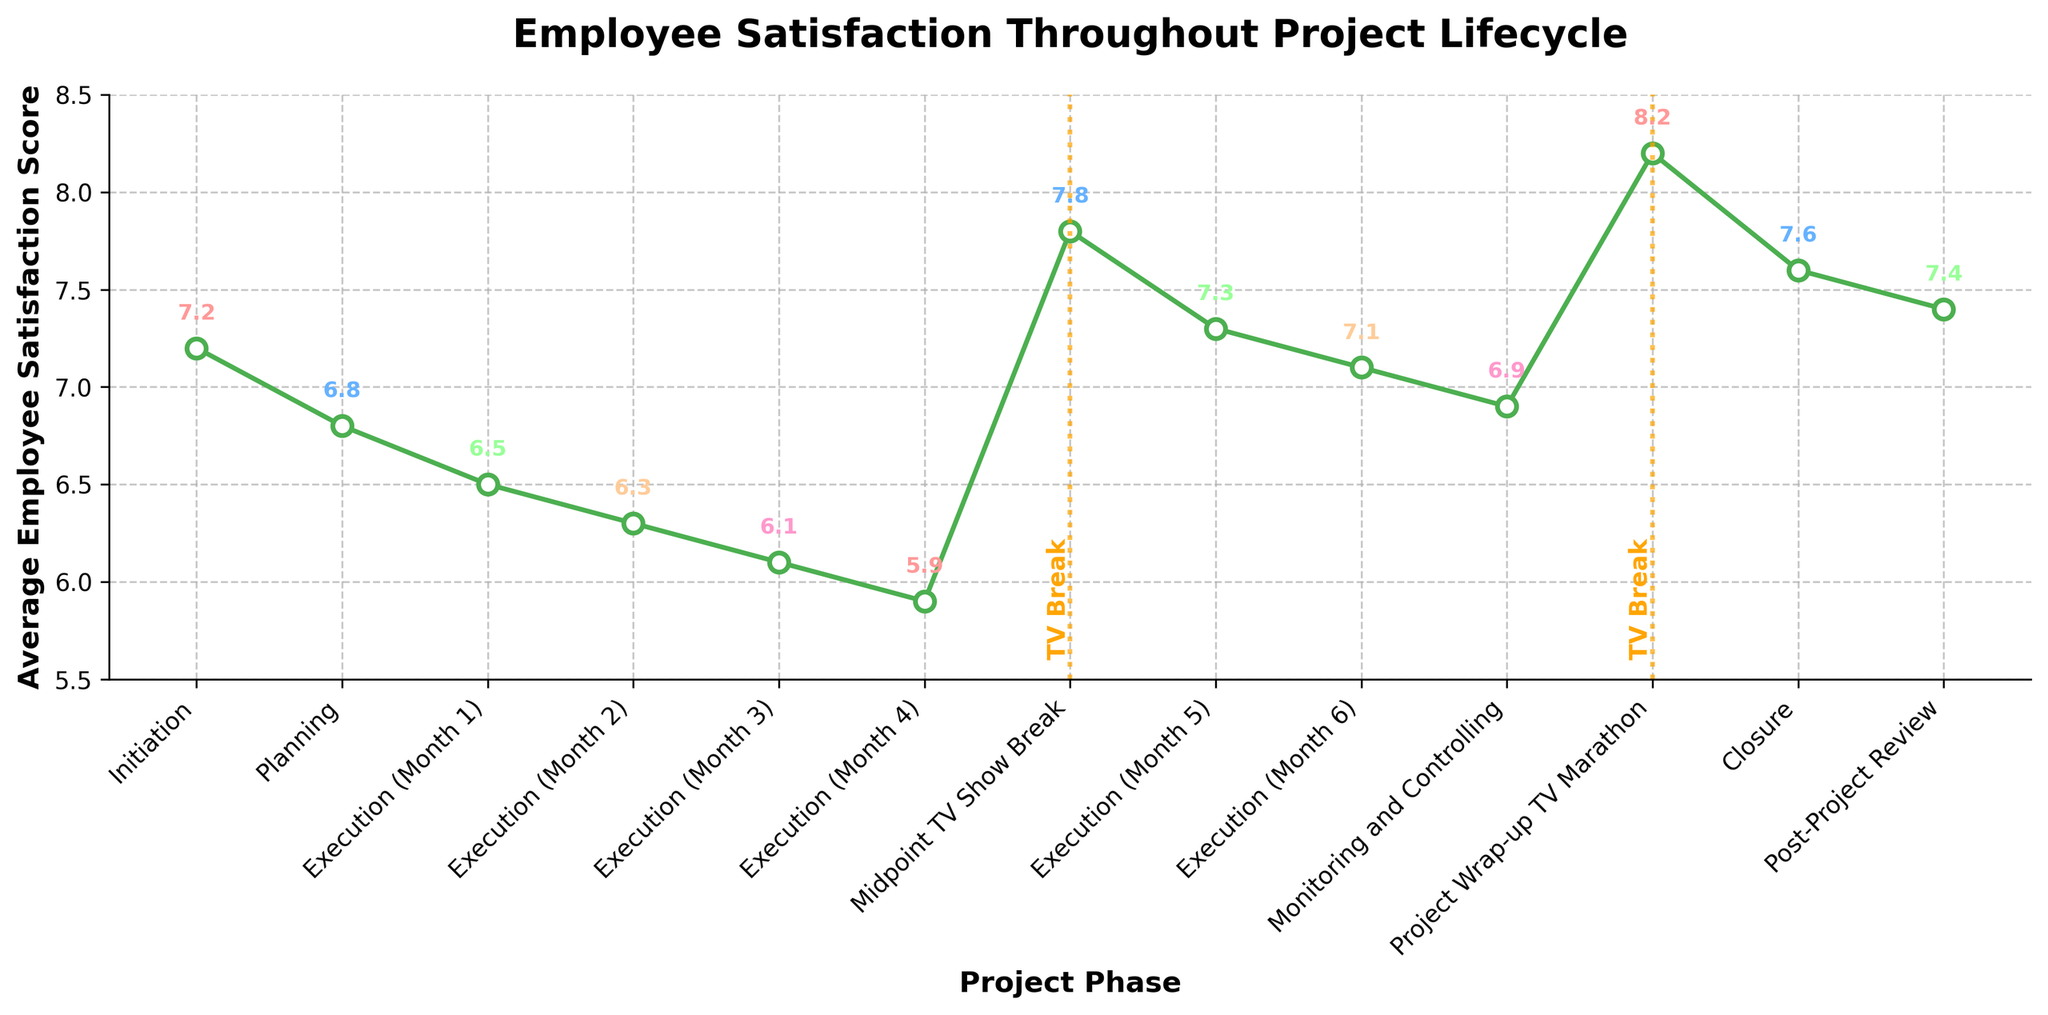What is the highest employee satisfaction score and in which phase does it occur? The highest score is observed during the 'Project Wrap-up TV Marathon' phase, where the figure shows a peak satisfaction score of 8.2.
Answer: 8.2, Project Wrap-up TV Marathon What is the difference in satisfaction scores between the 'Initiation' and 'Midpoint TV Show Break' phases? The score in the 'Initiation' phase is 7.2 and in the 'Midpoint TV Show Break' phase is 7.8. The difference is 7.8 - 7.2.
Answer: 0.6 During which phase is the lowest satisfaction score observed? The lowest satisfaction score is observed during 'Execution (Month 4)', indicated by a score of 5.9 on the figure.
Answer: Execution (Month 4) How does the employee satisfaction score change immediately after the 'Midpoint TV Show Break'? The score after the 'Midpoint TV Show Break' increases to 7.3 from the previous phase score of 5.9, indicating an improvement in employee satisfaction.
Answer: It increases to 7.3 Compare the employee satisfaction score during 'Monitoring and Controlling' with 'Execution (Month 6)'. Which phase has a higher score? The score for 'Monitoring and Controlling' is 6.9, while for 'Execution (Month 6)' it is 7.1. Therefore, 'Execution (Month 6)' has a slightly higher score.
Answer: Execution (Month 6) What is the average score of all the 'Execution' month phases? The scores for the 'Execution' month phases are: 6.5, 6.3, 6.1, 5.9, 7.3, and 7.1. Summing these gives 39.2, and there are 6 phases, so the average is 39.2/6 ≈ 6.53.
Answer: 6.53 Is the employee satisfaction score higher during the 'Closure' or the 'Post-Project Review'? The score during 'Closure' is 7.6, while during 'Post-Project Review' it is 7.4. 'Closure' has a higher score.
Answer: Closure Which phase marks the first decrease in the employee satisfaction score from the 'Initiation' phase? The first decrease is observed in the 'Planning' phase, where the score drops to 6.8 from 7.2 in 'Initiation'.
Answer: Planning By how much does the satisfaction score change from 'Execution (Month 1)' to 'Execution (Month 4)'? The satisfaction score decreases from 6.5 in 'Execution (Month 1)' to 5.9 in 'Execution (Month 4)', resulting in a change of 6.5 - 5.9.
Answer: 0.6 What visual indicator highlights the phases associated with TV breaks in the figure? The figure uses vertical orange dashed lines with the text 'TV Break' to highlight the phases associated with TV breaks, located at 'Midpoint TV Show Break' and 'Project Wrap-up TV Marathon'.
Answer: Vertical orange dashed lines with the text 'TV Break' 